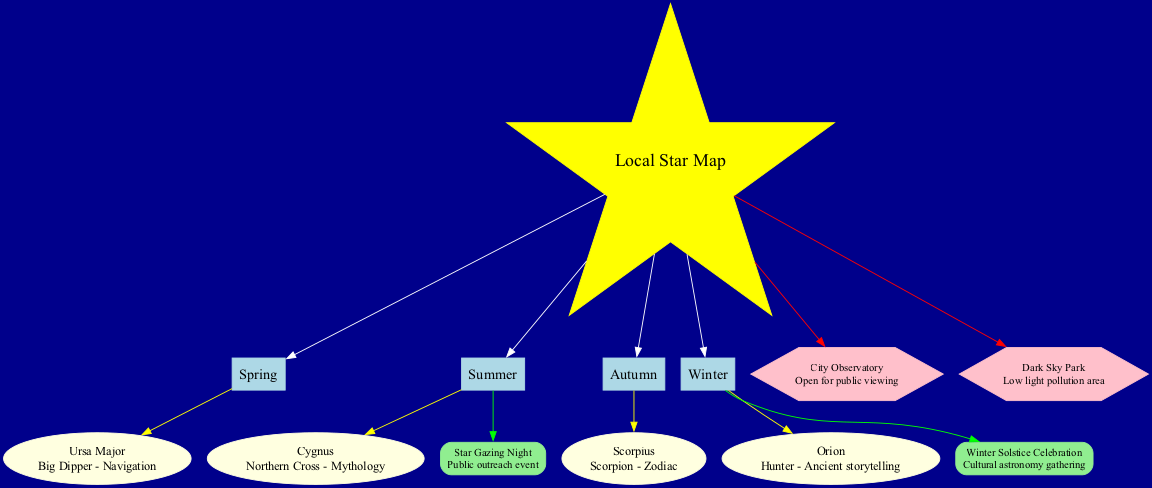What constellations can be seen in winter? The diagram indicates that the constellation visible in winter is Orion, listed along with its cultural significance.
Answer: Orion How many seasons are represented in the diagram? There are four seasons listed: Spring, Summer, Autumn, and Winter. Thus, the total number of seasons represented is four.
Answer: 4 What is the cultural significance of Cygnus? Cygnus is noted for its cultural significance as the Northern Cross, related to mythology. This information is found within its corresponding node in the diagram.
Answer: Northern Cross - Mythology Which community event occurs in summer? The diagram identifies the "Star Gazing Night" as the community event taking place in summer, illustrating the connection between the season and the event.
Answer: Star Gazing Night Which local landmark is described as an area with low light pollution? According to the diagram, the local landmark that is characterized by low light pollution is the Dark Sky Park, emphasized through its description node.
Answer: Dark Sky Park What constellation is associated with navigation? The constellation tied to navigation, as indicated in the diagram, is Ursa Major, marked specifically with its cultural significance for navigation in its node.
Answer: Ursa Major How many constellations are visible in spring? The diagram shows that there is one constellation listed for spring, which is Ursa Major. Thus, the count of visible constellations in spring is one.
Answer: 1 What type of shape represents community events in the diagram? The community events in the diagram are represented by rounded rectangles, as indicated by the shape assigned to those event nodes.
Answer: Box Which constellation has a cultural connection to zodiac signs? The constellation Scorpius is highlighted as having cultural significance related to zodiac signs, clearly described in its node within the diagram.
Answer: Scorpius 